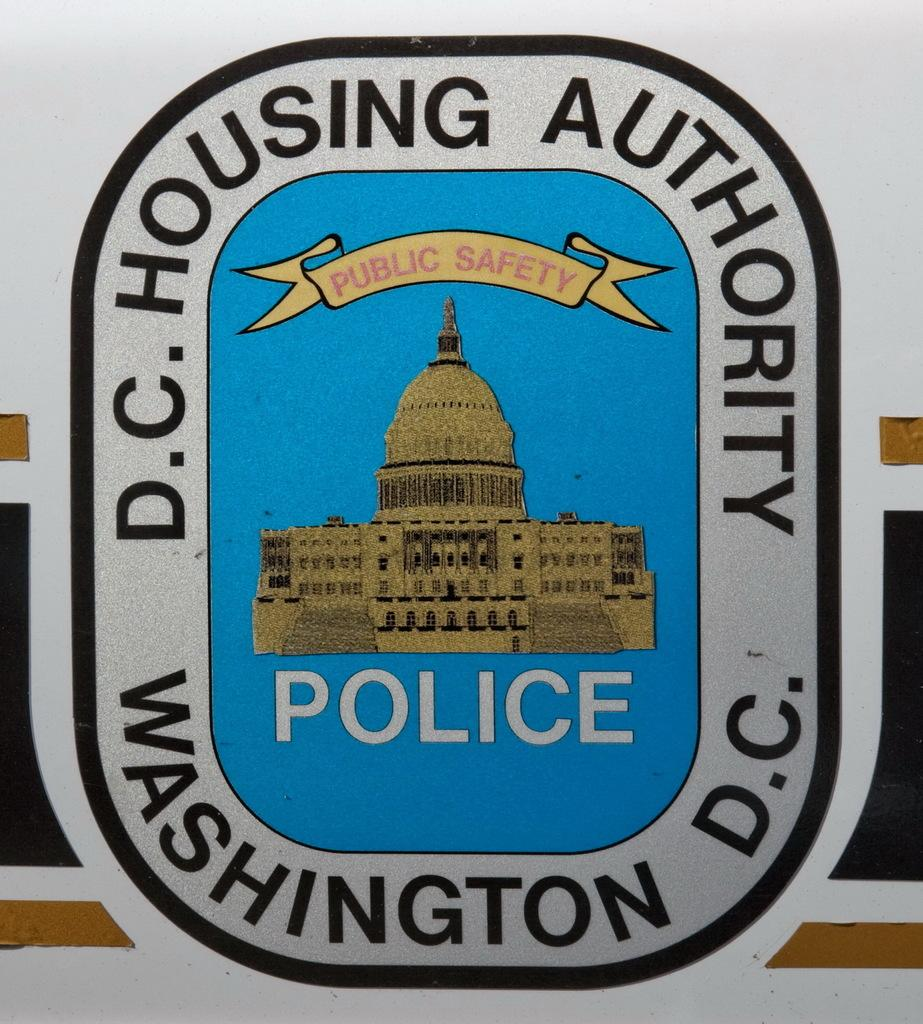<image>
Give a short and clear explanation of the subsequent image. A building on a sign for the police and the Washington D.C. housing Authority. 